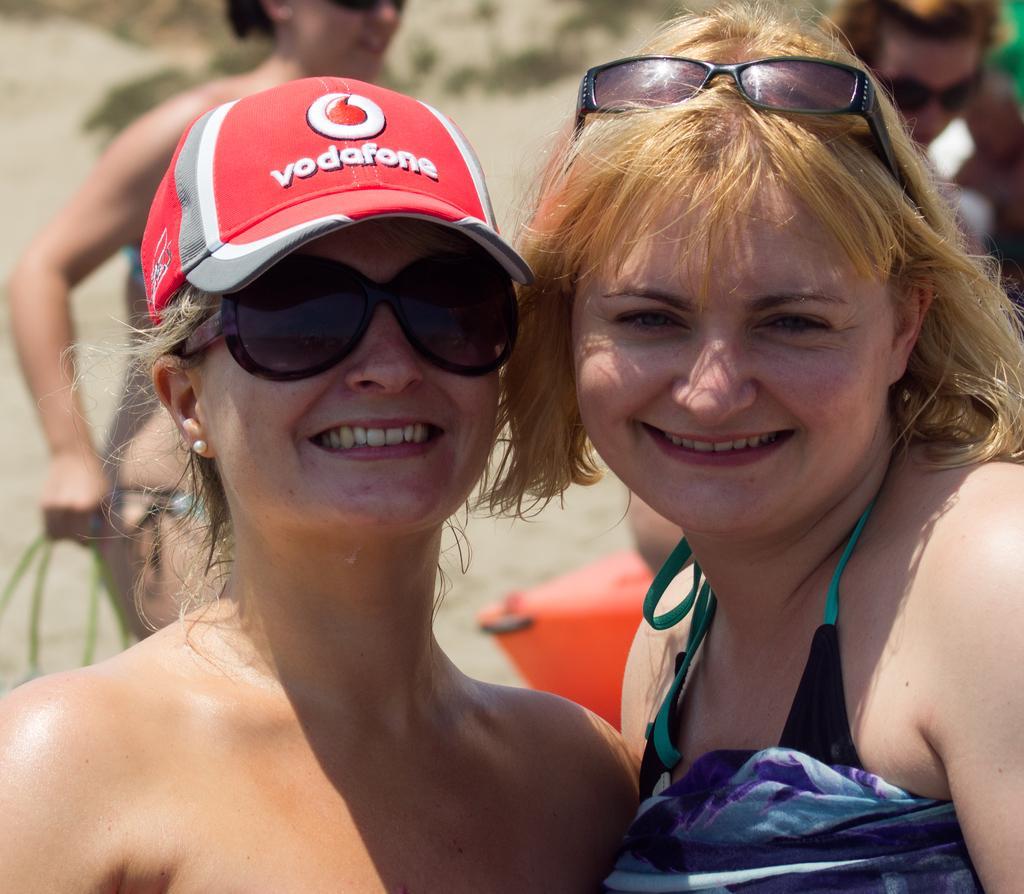Could you give a brief overview of what you see in this image? Here in this picture we can see two women present and both are smiling and the woman on the left side is wearing a cap and goggles on her and we can also see spectacles on the woman on the right side and behind them also we can see people standing over there. 